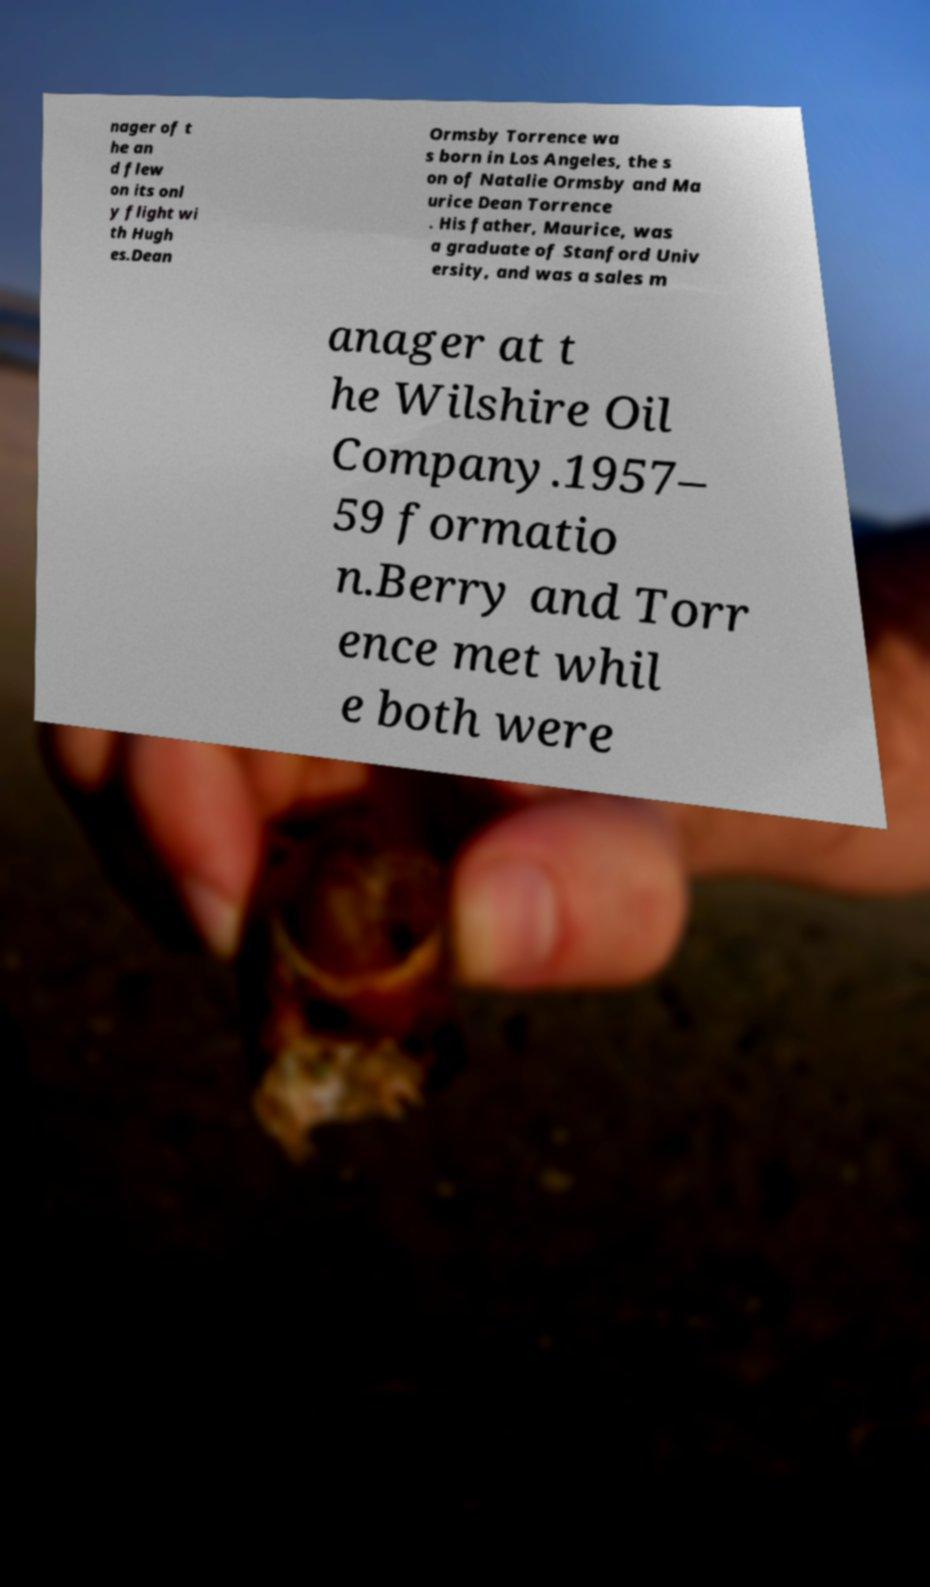I need the written content from this picture converted into text. Can you do that? nager of t he an d flew on its onl y flight wi th Hugh es.Dean Ormsby Torrence wa s born in Los Angeles, the s on of Natalie Ormsby and Ma urice Dean Torrence . His father, Maurice, was a graduate of Stanford Univ ersity, and was a sales m anager at t he Wilshire Oil Company.1957– 59 formatio n.Berry and Torr ence met whil e both were 